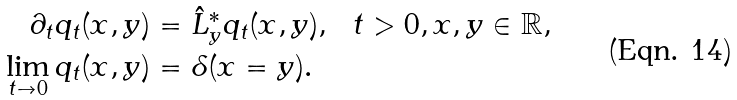<formula> <loc_0><loc_0><loc_500><loc_500>\partial _ { t } q _ { t } ( x , y ) & = \hat { L } _ { y } ^ { * } q _ { t } ( x , y ) , \ \ t > 0 , x , y \in \mathbb { R } , \\ \lim _ { t \to 0 } q _ { t } ( x , y ) & = \delta ( x = y ) .</formula> 